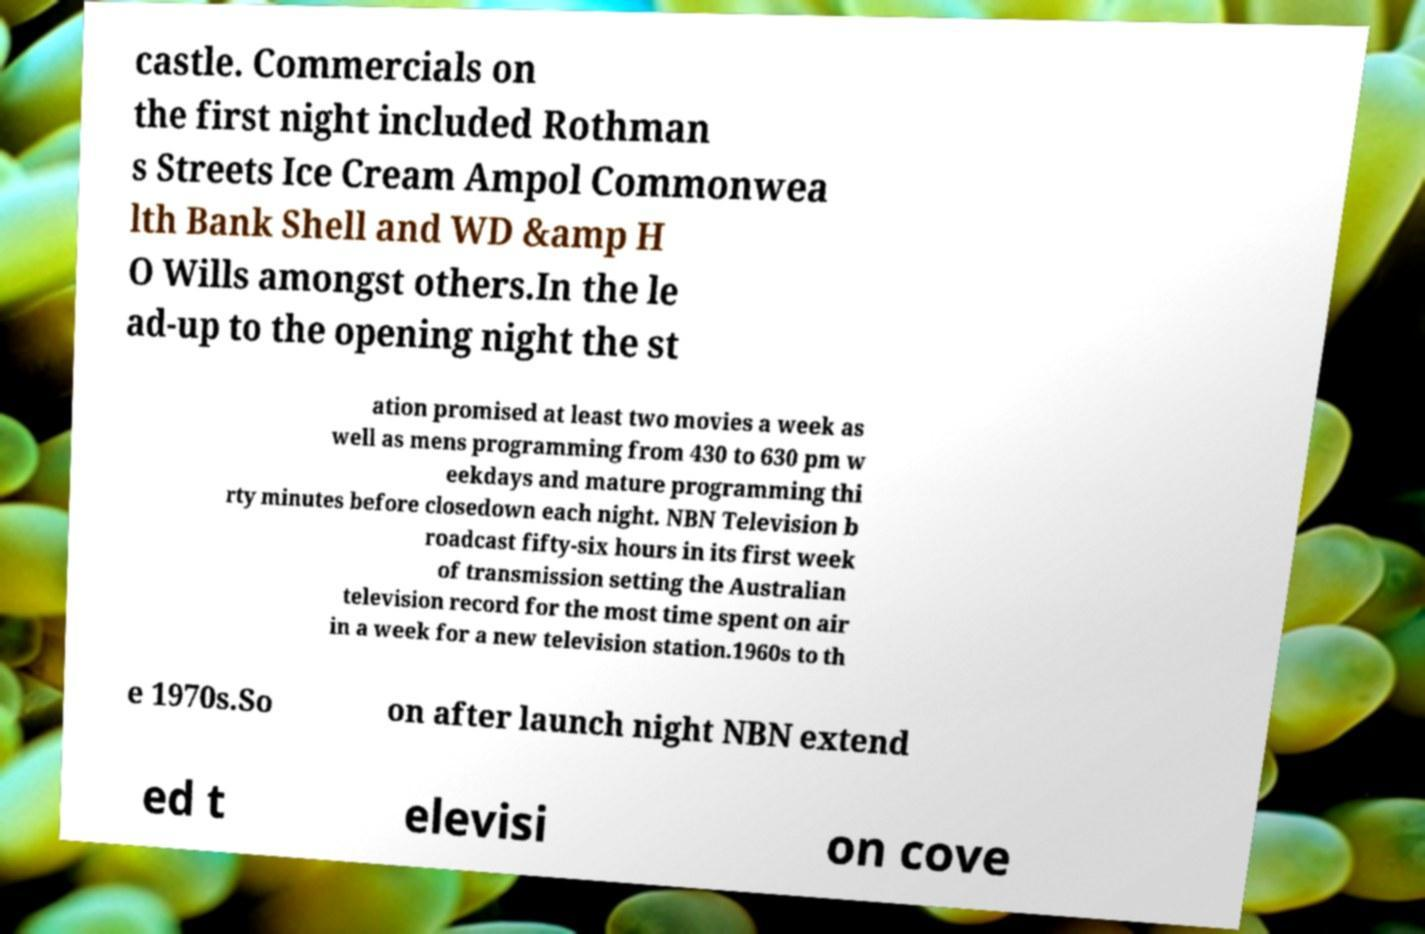What messages or text are displayed in this image? I need them in a readable, typed format. castle. Commercials on the first night included Rothman s Streets Ice Cream Ampol Commonwea lth Bank Shell and WD &amp H O Wills amongst others.In the le ad-up to the opening night the st ation promised at least two movies a week as well as mens programming from 430 to 630 pm w eekdays and mature programming thi rty minutes before closedown each night. NBN Television b roadcast fifty-six hours in its first week of transmission setting the Australian television record for the most time spent on air in a week for a new television station.1960s to th e 1970s.So on after launch night NBN extend ed t elevisi on cove 